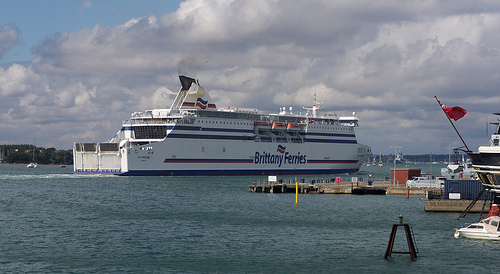Please provide the bounding box coordinate of the region this sentence describes: a long flag pole. The bounding box coordinates for the long flag pole are [0.86, 0.42, 0.95, 0.52]. 